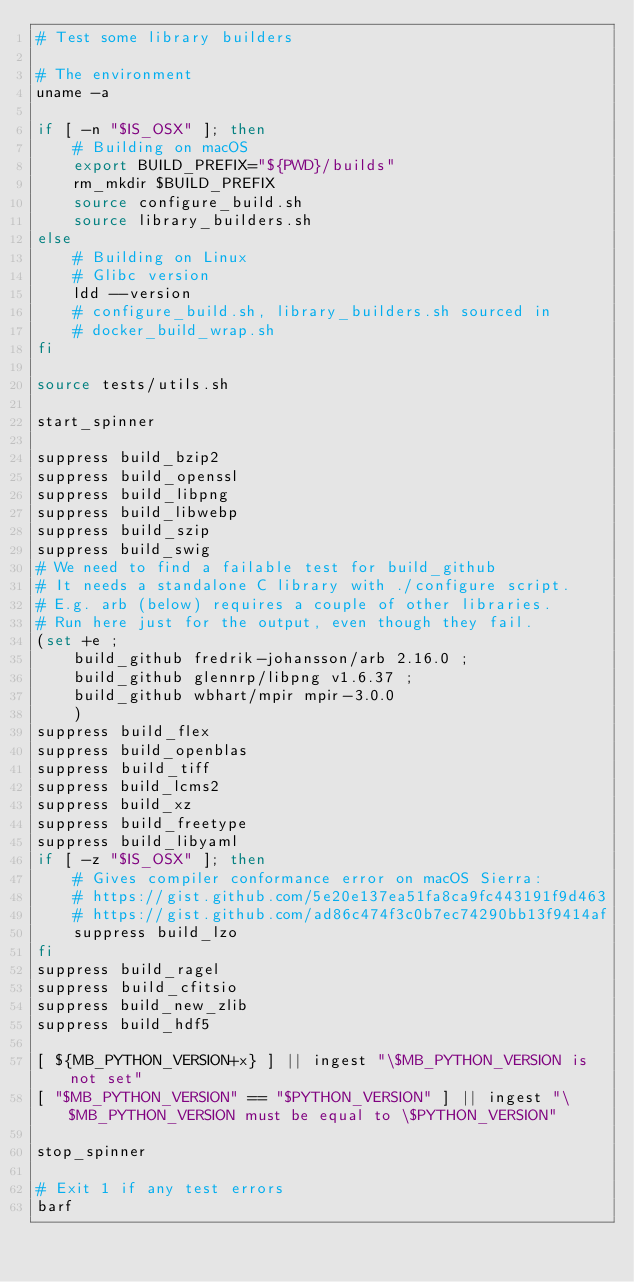<code> <loc_0><loc_0><loc_500><loc_500><_Bash_># Test some library builders

# The environment
uname -a

if [ -n "$IS_OSX" ]; then
    # Building on macOS
    export BUILD_PREFIX="${PWD}/builds"
    rm_mkdir $BUILD_PREFIX
    source configure_build.sh
    source library_builders.sh
else
    # Building on Linux
    # Glibc version
    ldd --version
    # configure_build.sh, library_builders.sh sourced in
    # docker_build_wrap.sh
fi

source tests/utils.sh

start_spinner

suppress build_bzip2
suppress build_openssl
suppress build_libpng
suppress build_libwebp
suppress build_szip
suppress build_swig
# We need to find a failable test for build_github
# It needs a standalone C library with ./configure script.
# E.g. arb (below) requires a couple of other libraries.
# Run here just for the output, even though they fail.
(set +e ;
    build_github fredrik-johansson/arb 2.16.0 ;
    build_github glennrp/libpng v1.6.37 ;
    build_github wbhart/mpir mpir-3.0.0
    )
suppress build_flex
suppress build_openblas
suppress build_tiff
suppress build_lcms2
suppress build_xz
suppress build_freetype
suppress build_libyaml
if [ -z "$IS_OSX" ]; then
    # Gives compiler conformance error on macOS Sierra:
    # https://gist.github.com/5e20e137ea51fa8ca9fc443191f9d463
    # https://gist.github.com/ad86c474f3c0b7ec74290bb13f9414af
    suppress build_lzo
fi
suppress build_ragel
suppress build_cfitsio
suppress build_new_zlib
suppress build_hdf5

[ ${MB_PYTHON_VERSION+x} ] || ingest "\$MB_PYTHON_VERSION is not set"
[ "$MB_PYTHON_VERSION" == "$PYTHON_VERSION" ] || ingest "\$MB_PYTHON_VERSION must be equal to \$PYTHON_VERSION"

stop_spinner

# Exit 1 if any test errors
barf
</code> 